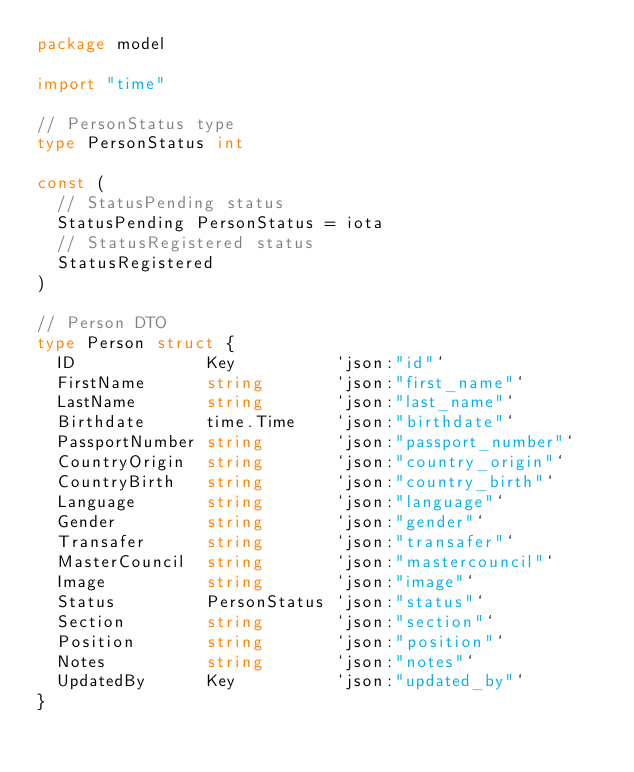Convert code to text. <code><loc_0><loc_0><loc_500><loc_500><_Go_>package model

import "time"

// PersonStatus type
type PersonStatus int

const (
	// StatusPending status
	StatusPending PersonStatus = iota
	// StatusRegistered status
	StatusRegistered
)

// Person DTO
type Person struct {
	ID             Key          `json:"id"`
	FirstName      string       `json:"first_name"`
	LastName       string       `json:"last_name"`
	Birthdate      time.Time    `json:"birthdate"`
	PassportNumber string       `json:"passport_number"`
	CountryOrigin  string       `json:"country_origin"`
	CountryBirth   string       `json:"country_birth"`
	Language       string       `json:"language"`
	Gender         string       `json:"gender"`
	Transafer      string       `json:"transafer"`
	MasterCouncil  string       `json:"mastercouncil"`
	Image          string       `json:"image"`
	Status         PersonStatus `json:"status"`
	Section        string       `json:"section"`
	Position       string       `json:"position"`
	Notes          string       `json:"notes"`
	UpdatedBy      Key          `json:"updated_by"`
}
</code> 